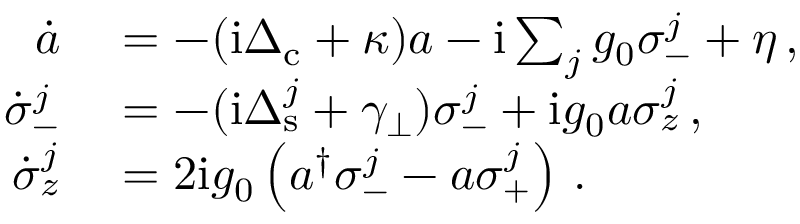Convert formula to latex. <formula><loc_0><loc_0><loc_500><loc_500>\begin{array} { r l } { \dot { a } } & = - ( i \Delta _ { c } + \kappa ) a - i \sum _ { j } g _ { 0 } \sigma _ { - } ^ { j } + \eta \, , } \\ { \dot { \sigma } _ { - } ^ { j } } & = - ( i \Delta _ { s } ^ { j } + \gamma _ { \perp } ) \sigma _ { - } ^ { j } + i g _ { 0 } a \sigma _ { z } ^ { j } \, , } \\ { \dot { \sigma } _ { z } ^ { j } } & = 2 i g _ { 0 } \left ( a ^ { \dagger } \sigma _ { - } ^ { j } - a \sigma _ { + } ^ { j } \right ) \, . } \end{array}</formula> 